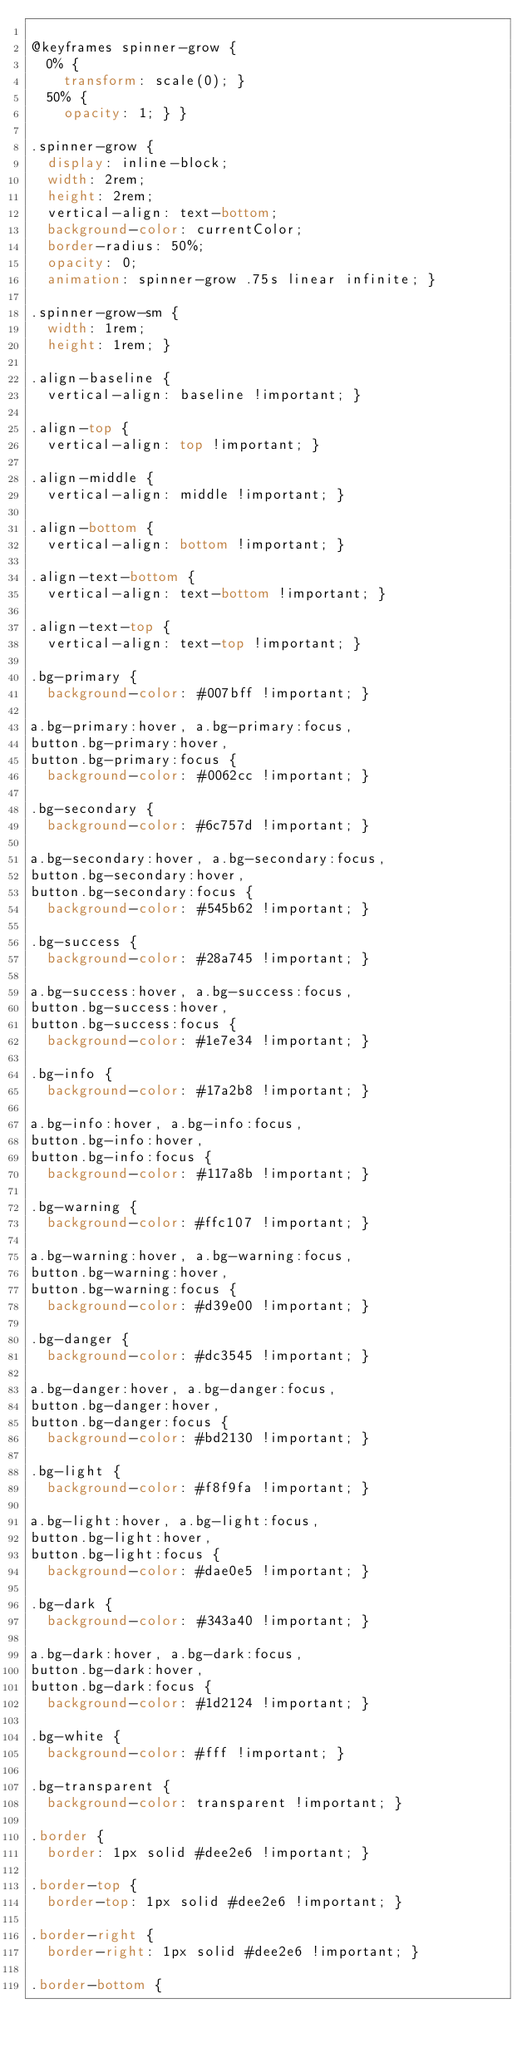Convert code to text. <code><loc_0><loc_0><loc_500><loc_500><_CSS_>
@keyframes spinner-grow {
  0% {
    transform: scale(0); }
  50% {
    opacity: 1; } }

.spinner-grow {
  display: inline-block;
  width: 2rem;
  height: 2rem;
  vertical-align: text-bottom;
  background-color: currentColor;
  border-radius: 50%;
  opacity: 0;
  animation: spinner-grow .75s linear infinite; }

.spinner-grow-sm {
  width: 1rem;
  height: 1rem; }

.align-baseline {
  vertical-align: baseline !important; }

.align-top {
  vertical-align: top !important; }

.align-middle {
  vertical-align: middle !important; }

.align-bottom {
  vertical-align: bottom !important; }

.align-text-bottom {
  vertical-align: text-bottom !important; }

.align-text-top {
  vertical-align: text-top !important; }

.bg-primary {
  background-color: #007bff !important; }

a.bg-primary:hover, a.bg-primary:focus,
button.bg-primary:hover,
button.bg-primary:focus {
  background-color: #0062cc !important; }

.bg-secondary {
  background-color: #6c757d !important; }

a.bg-secondary:hover, a.bg-secondary:focus,
button.bg-secondary:hover,
button.bg-secondary:focus {
  background-color: #545b62 !important; }

.bg-success {
  background-color: #28a745 !important; }

a.bg-success:hover, a.bg-success:focus,
button.bg-success:hover,
button.bg-success:focus {
  background-color: #1e7e34 !important; }

.bg-info {
  background-color: #17a2b8 !important; }

a.bg-info:hover, a.bg-info:focus,
button.bg-info:hover,
button.bg-info:focus {
  background-color: #117a8b !important; }

.bg-warning {
  background-color: #ffc107 !important; }

a.bg-warning:hover, a.bg-warning:focus,
button.bg-warning:hover,
button.bg-warning:focus {
  background-color: #d39e00 !important; }

.bg-danger {
  background-color: #dc3545 !important; }

a.bg-danger:hover, a.bg-danger:focus,
button.bg-danger:hover,
button.bg-danger:focus {
  background-color: #bd2130 !important; }

.bg-light {
  background-color: #f8f9fa !important; }

a.bg-light:hover, a.bg-light:focus,
button.bg-light:hover,
button.bg-light:focus {
  background-color: #dae0e5 !important; }

.bg-dark {
  background-color: #343a40 !important; }

a.bg-dark:hover, a.bg-dark:focus,
button.bg-dark:hover,
button.bg-dark:focus {
  background-color: #1d2124 !important; }

.bg-white {
  background-color: #fff !important; }

.bg-transparent {
  background-color: transparent !important; }

.border {
  border: 1px solid #dee2e6 !important; }

.border-top {
  border-top: 1px solid #dee2e6 !important; }

.border-right {
  border-right: 1px solid #dee2e6 !important; }

.border-bottom {</code> 